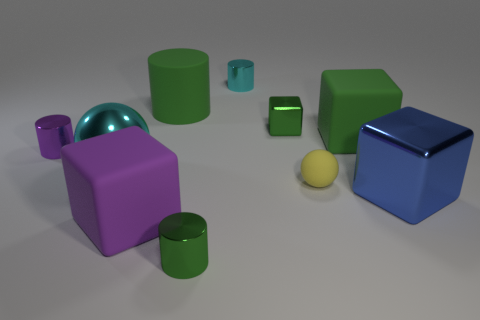How many metallic things are the same color as the large cylinder?
Offer a very short reply. 2. What is the size of the other metal object that is the same shape as the yellow thing?
Give a very brief answer. Large. What is the shape of the tiny matte thing on the right side of the small green object that is in front of the small yellow matte sphere?
Your response must be concise. Sphere. What number of cyan things are large blocks or metal balls?
Keep it short and to the point. 1. The large matte cylinder is what color?
Your answer should be very brief. Green. Is the size of the purple shiny object the same as the cyan cylinder?
Your response must be concise. Yes. Is there any other thing that is the same shape as the tiny cyan metal object?
Offer a terse response. Yes. Does the large green cube have the same material as the ball that is in front of the metal ball?
Make the answer very short. Yes. There is a small metallic cylinder that is left of the purple matte object; does it have the same color as the large metallic cube?
Make the answer very short. No. What number of shiny cylinders are both in front of the green metal cube and to the right of the small purple object?
Offer a terse response. 1. 